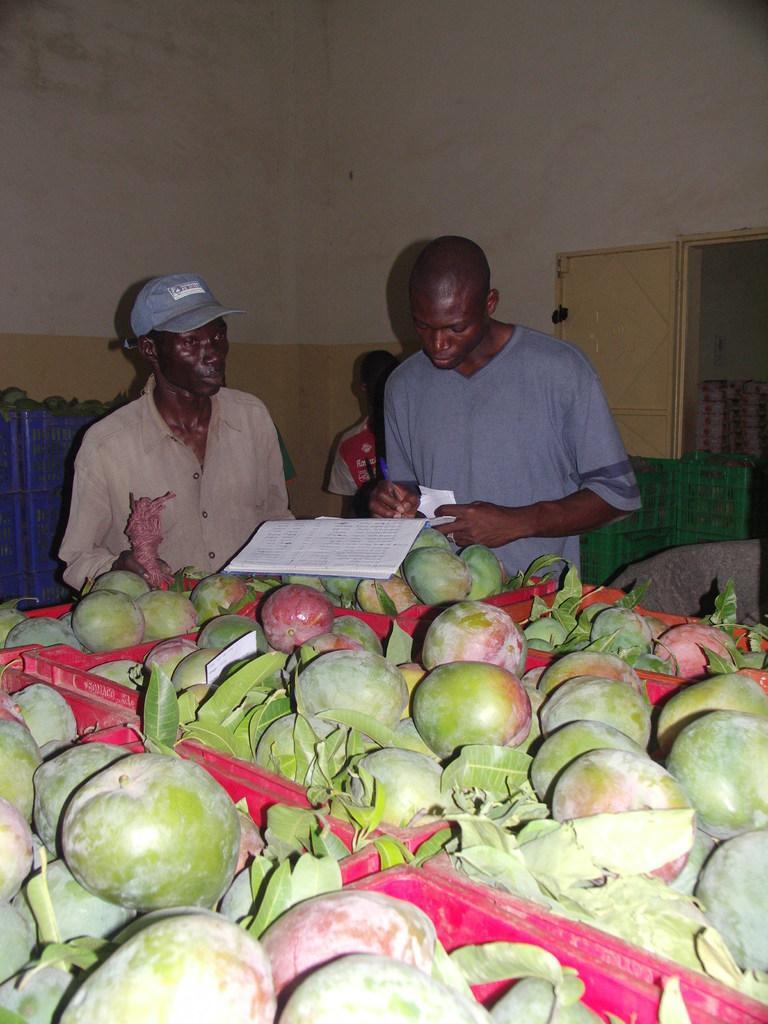Could you give a brief overview of what you see in this image? In this image there are a group of people standing beside the table writing something in book and also we can see there are so many raw mangoes. 